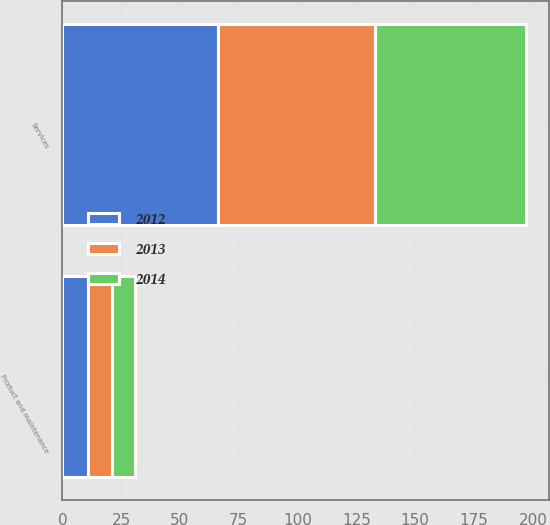<chart> <loc_0><loc_0><loc_500><loc_500><stacked_bar_chart><ecel><fcel>Product and maintenance<fcel>Services<nl><fcel>2012<fcel>11<fcel>66<nl><fcel>2013<fcel>10<fcel>67<nl><fcel>2014<fcel>10<fcel>64<nl></chart> 